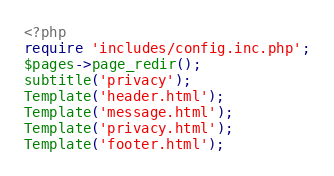Convert code to text. <code><loc_0><loc_0><loc_500><loc_500><_PHP_><?php
require 'includes/config.inc.php';
$pages->page_redir();
subtitle('privacy');
Template('header.html');
Template('message.html');
Template('privacy.html');
Template('footer.html');
</code> 